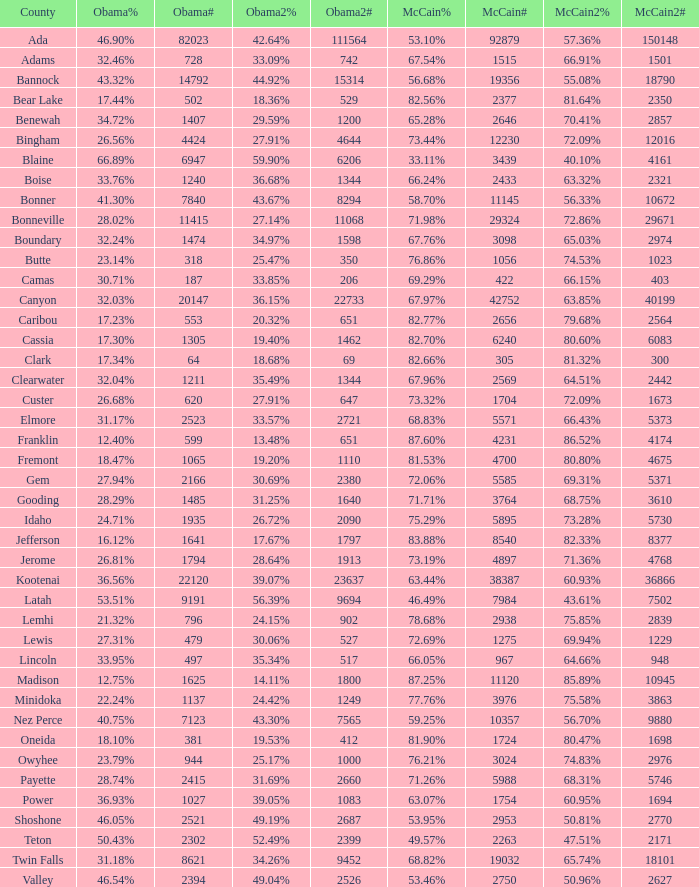What is the McCain vote percentage in Jerome county? 73.19%. 